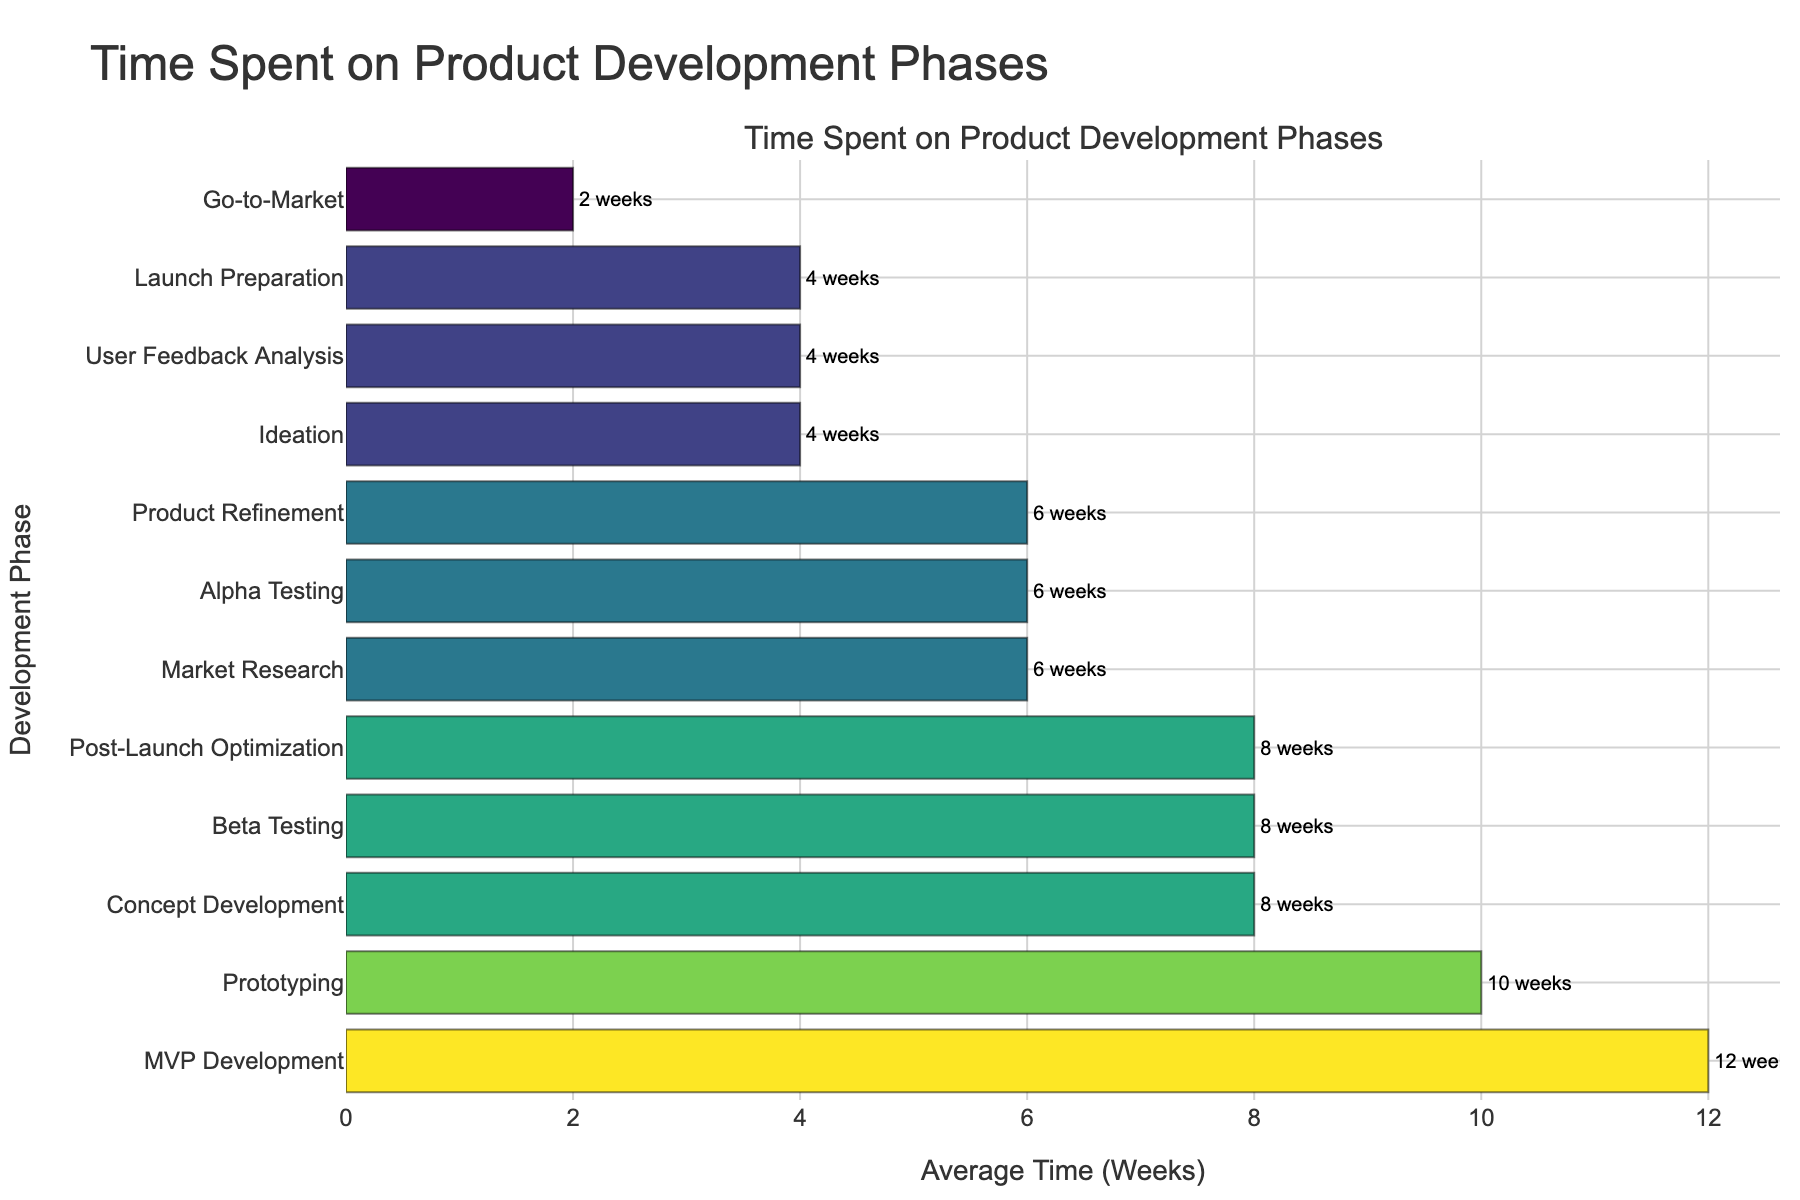Which phase takes the longest time on average? The longest bar on the chart represents the phase that takes the most time. By visually inspecting the chart, we see that MVP Development has the longest bar.
Answer: MVP Development How many phases take exactly 6 weeks on average? To find this, count the number of bars that are positioned at the 6-week mark. There are three phases: Market Research, Alpha Testing, and Product Refinement.
Answer: 3 What is the total average time spent on Ideation and Go-to-Market combined? Add the average times for Ideation (4 weeks) and Go-to-Market (2 weeks). 4 + 2 = 6 weeks.
Answer: 6 weeks Which phases take less than 5 weeks on average? Look for bars shorter than the 5-week mark. Ideation, User Feedback Analysis, Launch Preparation, and Go-to-Market are the phases that meet this criterion.
Answer: Ideation, User Feedback Analysis, Launch Preparation, Go-to-Market Is the average time spent on Prototyping greater than that on Market Research? Compare the lengths of the bars for Prototyping (10 weeks) and Market Research (6 weeks). Since 10 > 6, Prototyping takes more time.
Answer: Yes What is the difference in average time between the longest and shortest development phases? The longest phase is MVP Development (12 weeks) and the shortest is Go-to-Market (2 weeks). Subtract the shortest from the longest. 12 - 2 = 10 weeks.
Answer: 10 weeks Which phases have the same average time duration, and how long is it? Identify bars with identical lengths. Alpha Testing, Market Research, and Product Refinement all have bars at the 6-week mark.
Answer: Alpha Testing, Market Research, and Product Refinement; 6 weeks What is the combined average time spent on all phases that take exactly 8 weeks? Sum the times for Concept Development, Beta Testing, and Post-Launch Optimization. 8 + 8 + 8 = 24 weeks.
Answer: 24 weeks Is there a phase that takes the same amount of time as the combination of Go-to-Market and User Feedback Analysis? The combined time for Go-to-Market (2 weeks) and User Feedback Analysis (4 weeks) is 6 weeks. Alpha Testing, Market Research, and Product Refinement all take exactly 6 weeks.
Answer: Yes, Alpha Testing, Market Research, and Product Refinement Does the total average time spent on Beta Testing and Alpha Testing exceed the time spent on MVP Development? Add the times for Beta Testing (8 weeks) and Alpha Testing (6 weeks). 8 + 6 = 14 weeks. Comparing to MVP Development (12 weeks), 14 > 12.
Answer: Yes 